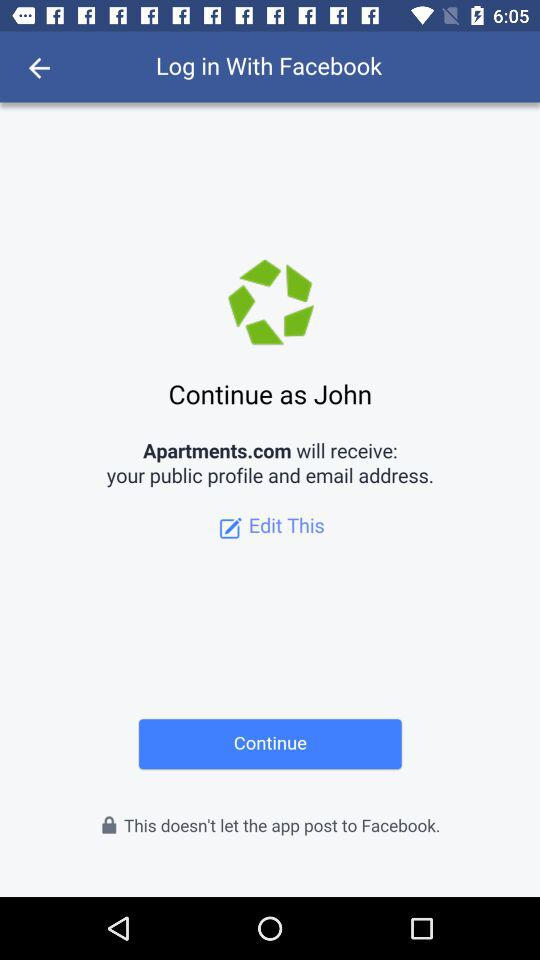What application will receive the public profile and email address? The public profile and email address will be received by "Apartments.com". 